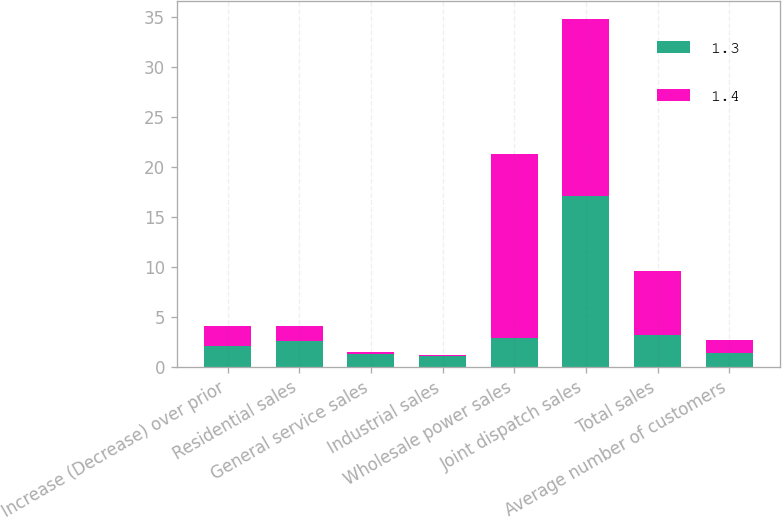Convert chart. <chart><loc_0><loc_0><loc_500><loc_500><stacked_bar_chart><ecel><fcel>Increase (Decrease) over prior<fcel>Residential sales<fcel>General service sales<fcel>Industrial sales<fcel>Wholesale power sales<fcel>Joint dispatch sales<fcel>Total sales<fcel>Average number of customers<nl><fcel>1.3<fcel>2.05<fcel>2.6<fcel>1.3<fcel>1.1<fcel>2.9<fcel>17.1<fcel>3.2<fcel>1.4<nl><fcel>1.4<fcel>2.05<fcel>1.5<fcel>0.2<fcel>0.1<fcel>18.4<fcel>17.7<fcel>6.4<fcel>1.3<nl></chart> 